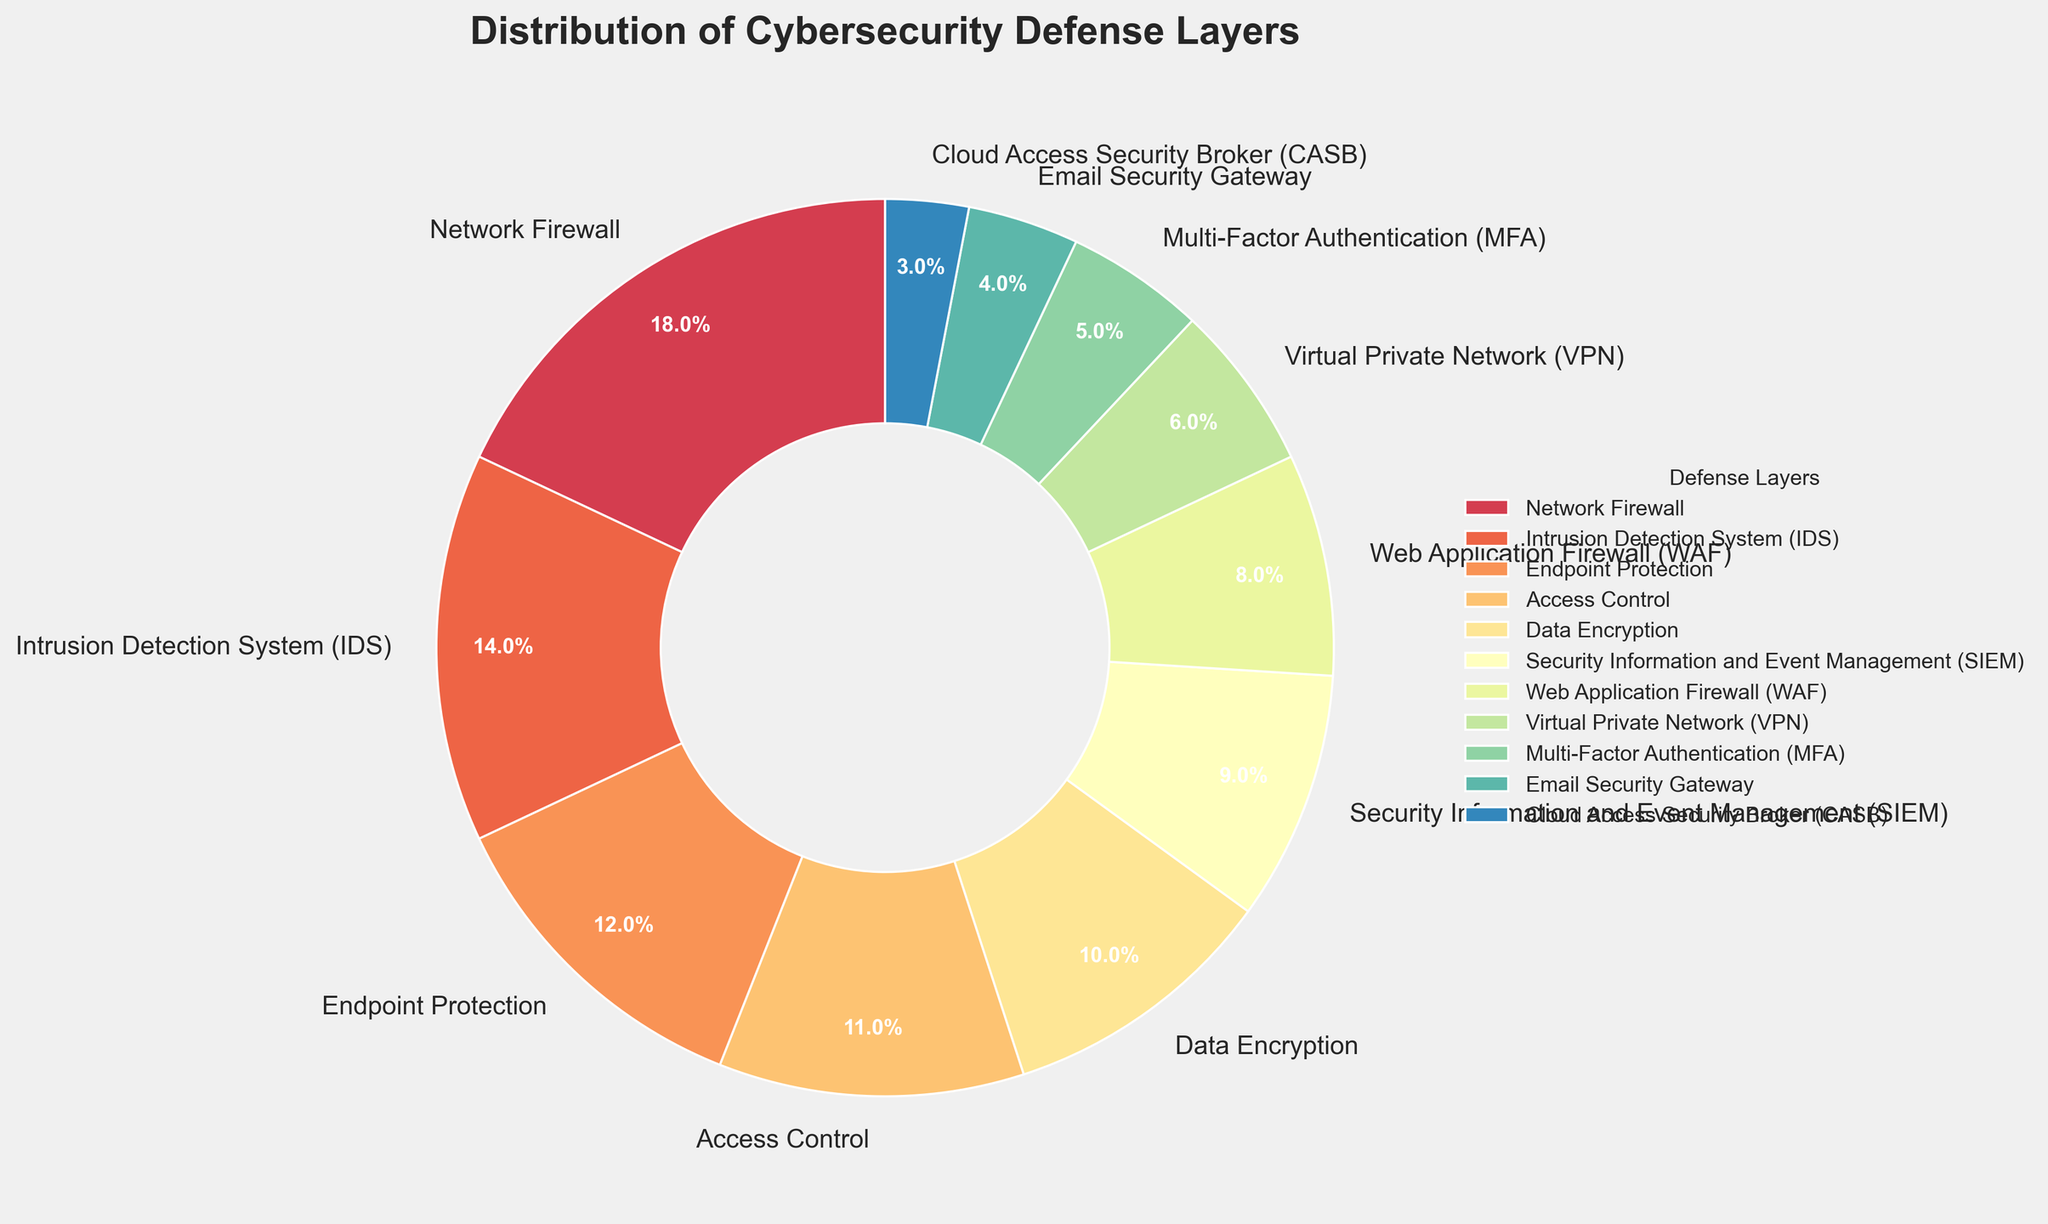What are the top three defense layers in terms of percentage? To find the top three defense layers, we need to identify the three largest percentages in the pie chart. They are Network Firewall (18%), Intrusion Detection System (IDS) (14%), and Endpoint Protection (12%).
Answer: Network Firewall, Intrusion Detection System (IDS), Endpoint Protection Which defense layer has the smallest percentage? By examining the pie chart, the defense layer with the smallest percentage is Cloud Access Security Broker (CASB) with 3%.
Answer: Cloud Access Security Broker (CASB) How many defense layers have a percentage greater than 10%? By looking at the pie chart, the layers with percentages greater than 10% are Network Firewall (18%), Intrusion Detection System (IDS) (14%), Endpoint Protection (12%), and Access Control (11%). This sums up to four layers.
Answer: Four What is the combined percentage of Network Firewall and Data Encryption? From the chart, Network Firewall has 18% and Data Encryption has 10%. Adding these two gives 18% + 10% = 28%.
Answer: 28% Is Access Control more or less than Multi-Factor Authentication (MFA) in percentage, and by how much? Access Control has 11% and Multi-Factor Authentication (MFA) has 5%. Access Control is more than MFA by 11% - 5% = 6%.
Answer: More, by 6% If we combine the percentages of Web Application Firewall (WAF) and Email Security Gateway, what is the total? WAF has 8% and Email Security Gateway has 4%. Adding these two together provides 8% + 4% = 12%.
Answer: 12% Which has a higher percentage, Security Information and Event Management (SIEM) or Virtual Private Network (VPN), and by what percentage? SIEM has a percentage of 9% whereas VPN has 6%. SIEM is higher by 9% - 6% = 3%.
Answer: SIEM, by 3% What is the sum of the percentages of the three smallest defense layers? The three smallest layers are Cloud Access Security Broker (CASB) with 3%, Email Security Gateway with 4%, and Multi-Factor Authentication (MFA) with 5%. Adding these gives 3% + 4% + 5% = 12%.
Answer: 12% What is the percentage difference between Endpoint Protection and Web Application Firewall (WAF)? Endpoint Protection has 12% and Web Application Firewall has 8%. The difference is 12% - 8% = 4%.
Answer: 4% Which defense layer is approximately one-sixth of the total distribution? The total distribution is 100%. One-sixth of 100% is approximately 16.67%. Examining the defense layers, Intrusion Detection System (IDS) with 14% is closest to one-sixth.
Answer: Intrusion Detection System (IDS) 